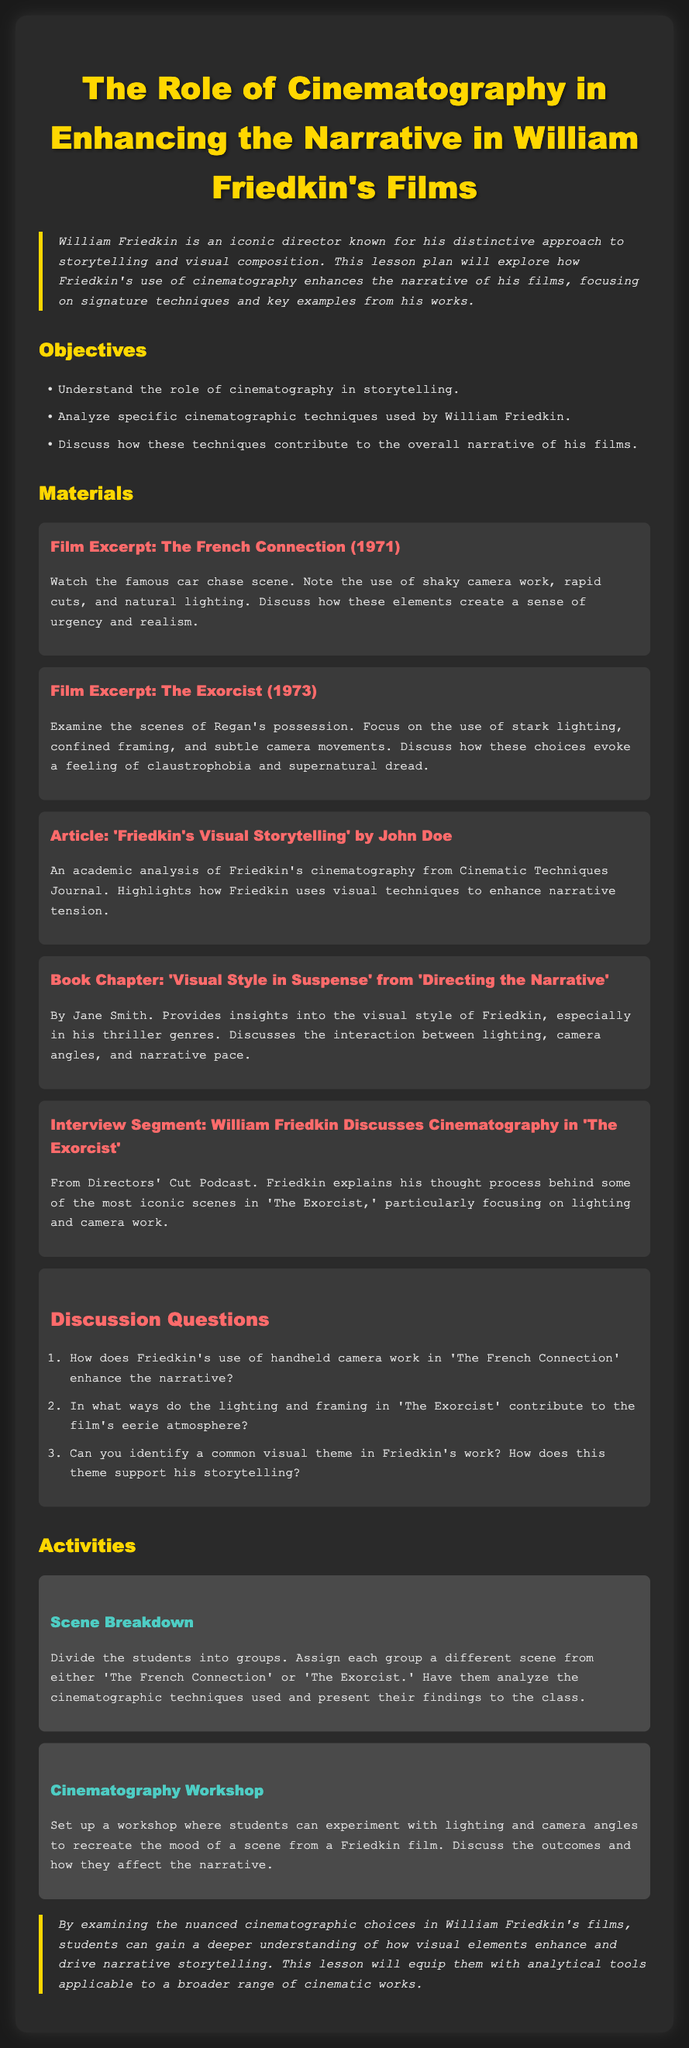What is the title of the lesson plan? The title of the lesson plan is provided in the document's header section.
Answer: The Role of Cinematography in Enhancing the Narrative in William Friedkin's Films Who is the director discussed in the lesson plan? The document discusses William Friedkin and his filmmaking techniques.
Answer: William Friedkin What are the two films highlighted in the materials section? The materials section lists specific films used for analysis, focusing on two key works.
Answer: The French Connection and The Exorcist What year was 'The French Connection' released? The document includes the release year of the film in the excerpt description.
Answer: 1971 What type of lighting is examined in 'The Exorcist'? The materials suggest discussing specific lighting techniques in the film.
Answer: Stark lighting How many discussion questions are provided in the lesson plan? The document contains a specific number of discussion questions listed under the relevant section.
Answer: Three What is one key cinematographic technique mentioned for 'The French Connection'? The lesson plan indicates specific techniques used in the context of Friedkin's work in this film.
Answer: Handheld camera work What is the purpose of the cinematography workshop activity? The document outlines the objective of the activity focused on practical cinematography techniques.
Answer: Experiment with lighting and camera angles What genre is primarily discussed in the book chapter from 'Directing the Narrative'? The materials section refers to the specific genre related to Friedkin’s style in the book chapter.
Answer: Thriller 